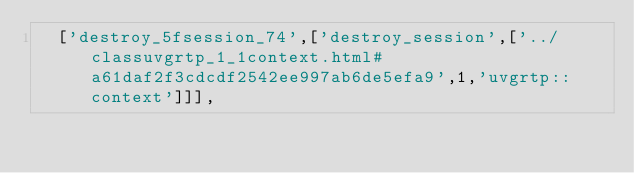Convert code to text. <code><loc_0><loc_0><loc_500><loc_500><_JavaScript_>  ['destroy_5fsession_74',['destroy_session',['../classuvgrtp_1_1context.html#a61daf2f3cdcdf2542ee997ab6de5efa9',1,'uvgrtp::context']]],</code> 